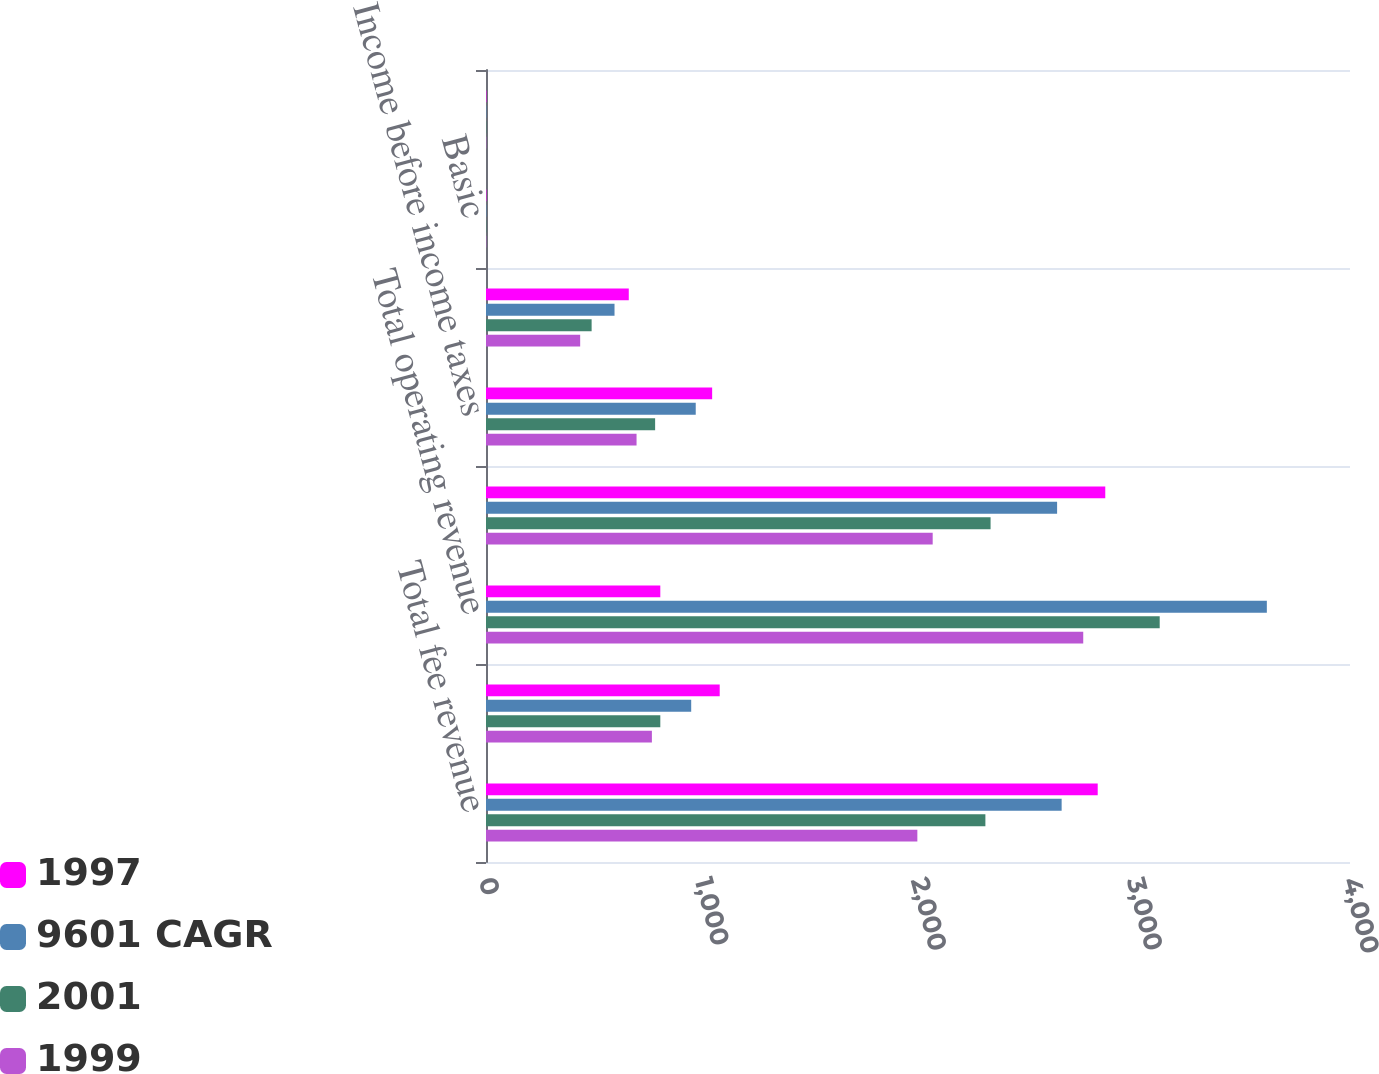Convert chart. <chart><loc_0><loc_0><loc_500><loc_500><stacked_bar_chart><ecel><fcel>Total fee revenue<fcel>Net interest revenue after<fcel>Total operating revenue<fcel>Operating expenses<fcel>Income before income taxes<fcel>Operating earnings<fcel>Basic<fcel>Diluted<nl><fcel>1997<fcel>2832<fcel>1082<fcel>807<fcel>2867<fcel>1047<fcel>661<fcel>2.03<fcel>2<nl><fcel>9601 CAGR<fcel>2665<fcel>950<fcel>3615<fcel>2644<fcel>971<fcel>595<fcel>1.85<fcel>1.81<nl><fcel>2001<fcel>2312<fcel>807<fcel>3119<fcel>2336<fcel>783<fcel>489<fcel>1.52<fcel>1.49<nl><fcel>1999<fcel>1997<fcel>768<fcel>2765<fcel>2068<fcel>697<fcel>436<fcel>1.35<fcel>1.33<nl></chart> 